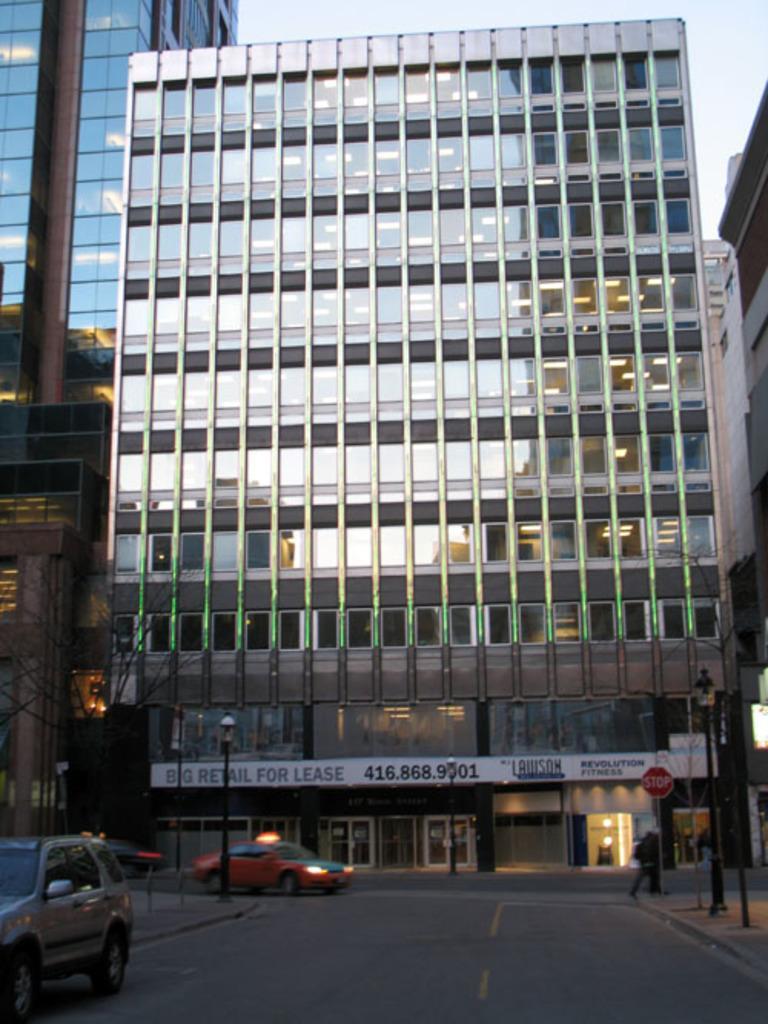How would you summarize this image in a sentence or two? In this image I can see some buildings. I can see a board on a building with some text. I can see light poles and other sign boards. I can see cars on the road I can see a tree a person walking on the road 